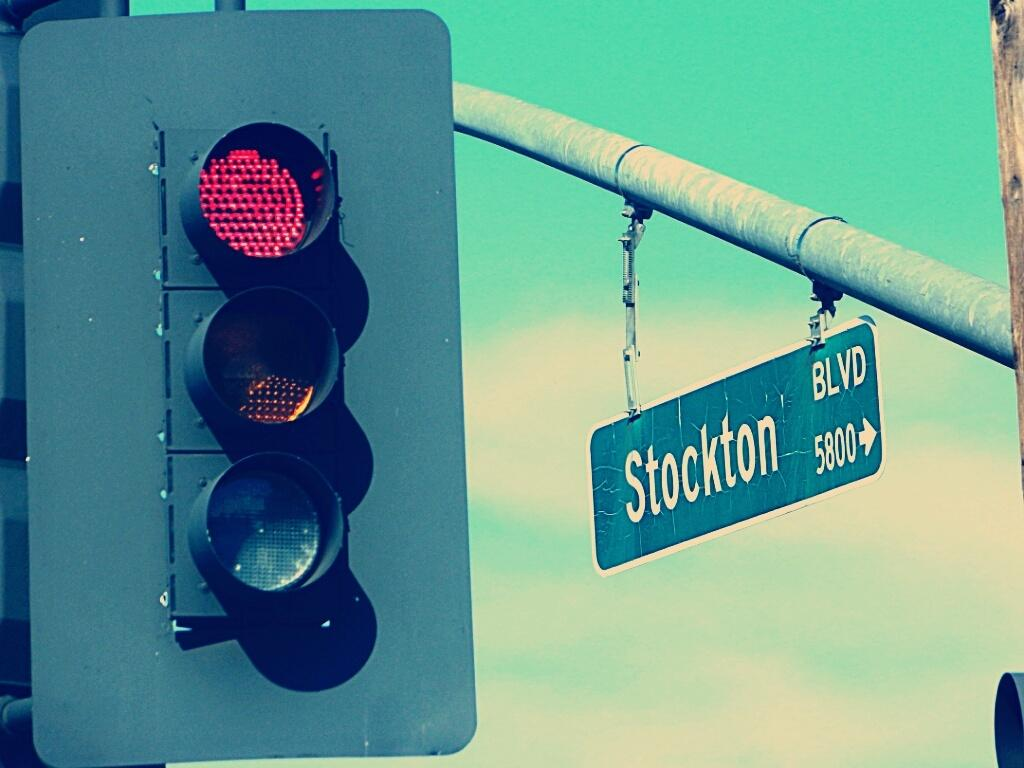<image>
Create a compact narrative representing the image presented. Stockton Blvd # 5800 sign with a red light at an intersection. 